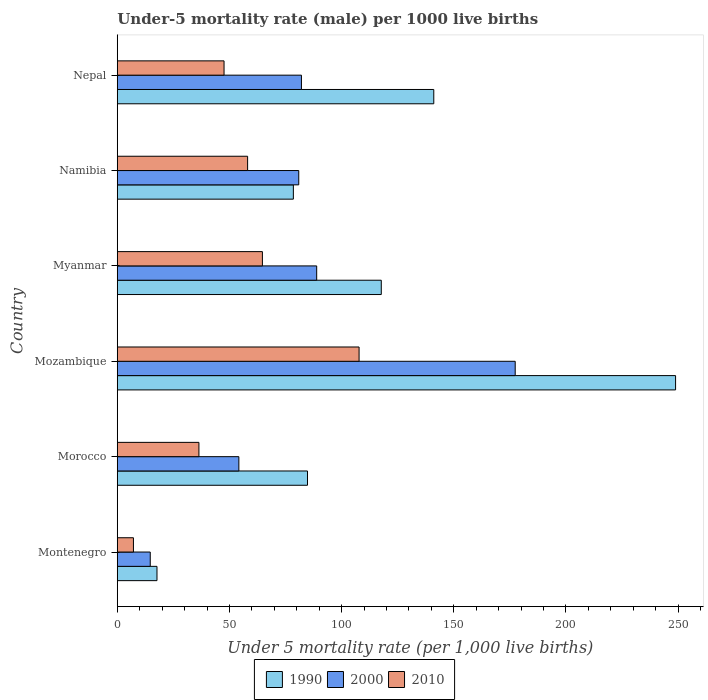How many groups of bars are there?
Ensure brevity in your answer.  6. How many bars are there on the 4th tick from the top?
Your answer should be compact. 3. What is the label of the 5th group of bars from the top?
Keep it short and to the point. Morocco. What is the under-five mortality rate in 1990 in Morocco?
Keep it short and to the point. 84.8. Across all countries, what is the maximum under-five mortality rate in 1990?
Make the answer very short. 248.9. Across all countries, what is the minimum under-five mortality rate in 1990?
Make the answer very short. 17.7. In which country was the under-five mortality rate in 2000 maximum?
Make the answer very short. Mozambique. In which country was the under-five mortality rate in 1990 minimum?
Your answer should be very brief. Montenegro. What is the total under-five mortality rate in 2000 in the graph?
Offer a terse response. 498.2. What is the difference between the under-five mortality rate in 2000 in Namibia and that in Nepal?
Your answer should be compact. -1.2. What is the difference between the under-five mortality rate in 1990 in Namibia and the under-five mortality rate in 2010 in Montenegro?
Offer a terse response. 71.3. What is the average under-five mortality rate in 2000 per country?
Keep it short and to the point. 83.03. In how many countries, is the under-five mortality rate in 2010 greater than 250 ?
Offer a terse response. 0. What is the ratio of the under-five mortality rate in 1990 in Mozambique to that in Myanmar?
Your answer should be very brief. 2.11. Is the difference between the under-five mortality rate in 2010 in Montenegro and Nepal greater than the difference between the under-five mortality rate in 1990 in Montenegro and Nepal?
Your response must be concise. Yes. What is the difference between the highest and the second highest under-five mortality rate in 1990?
Your answer should be compact. 107.8. What is the difference between the highest and the lowest under-five mortality rate in 1990?
Provide a succinct answer. 231.2. What does the 1st bar from the bottom in Morocco represents?
Make the answer very short. 1990. Is it the case that in every country, the sum of the under-five mortality rate in 2000 and under-five mortality rate in 1990 is greater than the under-five mortality rate in 2010?
Keep it short and to the point. Yes. Are all the bars in the graph horizontal?
Your response must be concise. Yes. How many countries are there in the graph?
Provide a succinct answer. 6. How many legend labels are there?
Your response must be concise. 3. What is the title of the graph?
Ensure brevity in your answer.  Under-5 mortality rate (male) per 1000 live births. What is the label or title of the X-axis?
Offer a very short reply. Under 5 mortality rate (per 1,0 live births). What is the Under 5 mortality rate (per 1,000 live births) in 1990 in Montenegro?
Make the answer very short. 17.7. What is the Under 5 mortality rate (per 1,000 live births) of 2000 in Montenegro?
Your answer should be compact. 14.7. What is the Under 5 mortality rate (per 1,000 live births) in 2010 in Montenegro?
Keep it short and to the point. 7.2. What is the Under 5 mortality rate (per 1,000 live births) of 1990 in Morocco?
Keep it short and to the point. 84.8. What is the Under 5 mortality rate (per 1,000 live births) in 2000 in Morocco?
Keep it short and to the point. 54.2. What is the Under 5 mortality rate (per 1,000 live births) of 2010 in Morocco?
Offer a very short reply. 36.4. What is the Under 5 mortality rate (per 1,000 live births) in 1990 in Mozambique?
Offer a terse response. 248.9. What is the Under 5 mortality rate (per 1,000 live births) in 2000 in Mozambique?
Keep it short and to the point. 177.4. What is the Under 5 mortality rate (per 1,000 live births) of 2010 in Mozambique?
Make the answer very short. 107.8. What is the Under 5 mortality rate (per 1,000 live births) of 1990 in Myanmar?
Offer a very short reply. 117.7. What is the Under 5 mortality rate (per 1,000 live births) in 2000 in Myanmar?
Keep it short and to the point. 88.9. What is the Under 5 mortality rate (per 1,000 live births) of 2010 in Myanmar?
Give a very brief answer. 64.7. What is the Under 5 mortality rate (per 1,000 live births) in 1990 in Namibia?
Your response must be concise. 78.5. What is the Under 5 mortality rate (per 1,000 live births) in 2000 in Namibia?
Your response must be concise. 80.9. What is the Under 5 mortality rate (per 1,000 live births) of 2010 in Namibia?
Your answer should be compact. 58.1. What is the Under 5 mortality rate (per 1,000 live births) in 1990 in Nepal?
Ensure brevity in your answer.  141.1. What is the Under 5 mortality rate (per 1,000 live births) of 2000 in Nepal?
Keep it short and to the point. 82.1. What is the Under 5 mortality rate (per 1,000 live births) of 2010 in Nepal?
Offer a very short reply. 47.6. Across all countries, what is the maximum Under 5 mortality rate (per 1,000 live births) in 1990?
Offer a very short reply. 248.9. Across all countries, what is the maximum Under 5 mortality rate (per 1,000 live births) in 2000?
Offer a terse response. 177.4. Across all countries, what is the maximum Under 5 mortality rate (per 1,000 live births) in 2010?
Keep it short and to the point. 107.8. Across all countries, what is the minimum Under 5 mortality rate (per 1,000 live births) of 1990?
Provide a succinct answer. 17.7. Across all countries, what is the minimum Under 5 mortality rate (per 1,000 live births) in 2000?
Offer a terse response. 14.7. What is the total Under 5 mortality rate (per 1,000 live births) in 1990 in the graph?
Provide a succinct answer. 688.7. What is the total Under 5 mortality rate (per 1,000 live births) of 2000 in the graph?
Provide a succinct answer. 498.2. What is the total Under 5 mortality rate (per 1,000 live births) in 2010 in the graph?
Your response must be concise. 321.8. What is the difference between the Under 5 mortality rate (per 1,000 live births) of 1990 in Montenegro and that in Morocco?
Your answer should be compact. -67.1. What is the difference between the Under 5 mortality rate (per 1,000 live births) in 2000 in Montenegro and that in Morocco?
Ensure brevity in your answer.  -39.5. What is the difference between the Under 5 mortality rate (per 1,000 live births) of 2010 in Montenegro and that in Morocco?
Your answer should be compact. -29.2. What is the difference between the Under 5 mortality rate (per 1,000 live births) in 1990 in Montenegro and that in Mozambique?
Give a very brief answer. -231.2. What is the difference between the Under 5 mortality rate (per 1,000 live births) in 2000 in Montenegro and that in Mozambique?
Provide a succinct answer. -162.7. What is the difference between the Under 5 mortality rate (per 1,000 live births) of 2010 in Montenegro and that in Mozambique?
Offer a very short reply. -100.6. What is the difference between the Under 5 mortality rate (per 1,000 live births) in 1990 in Montenegro and that in Myanmar?
Provide a succinct answer. -100. What is the difference between the Under 5 mortality rate (per 1,000 live births) of 2000 in Montenegro and that in Myanmar?
Offer a terse response. -74.2. What is the difference between the Under 5 mortality rate (per 1,000 live births) of 2010 in Montenegro and that in Myanmar?
Your answer should be very brief. -57.5. What is the difference between the Under 5 mortality rate (per 1,000 live births) in 1990 in Montenegro and that in Namibia?
Make the answer very short. -60.8. What is the difference between the Under 5 mortality rate (per 1,000 live births) in 2000 in Montenegro and that in Namibia?
Provide a short and direct response. -66.2. What is the difference between the Under 5 mortality rate (per 1,000 live births) of 2010 in Montenegro and that in Namibia?
Your answer should be compact. -50.9. What is the difference between the Under 5 mortality rate (per 1,000 live births) in 1990 in Montenegro and that in Nepal?
Your answer should be compact. -123.4. What is the difference between the Under 5 mortality rate (per 1,000 live births) of 2000 in Montenegro and that in Nepal?
Give a very brief answer. -67.4. What is the difference between the Under 5 mortality rate (per 1,000 live births) in 2010 in Montenegro and that in Nepal?
Your answer should be very brief. -40.4. What is the difference between the Under 5 mortality rate (per 1,000 live births) of 1990 in Morocco and that in Mozambique?
Make the answer very short. -164.1. What is the difference between the Under 5 mortality rate (per 1,000 live births) in 2000 in Morocco and that in Mozambique?
Offer a very short reply. -123.2. What is the difference between the Under 5 mortality rate (per 1,000 live births) of 2010 in Morocco and that in Mozambique?
Offer a very short reply. -71.4. What is the difference between the Under 5 mortality rate (per 1,000 live births) of 1990 in Morocco and that in Myanmar?
Provide a succinct answer. -32.9. What is the difference between the Under 5 mortality rate (per 1,000 live births) in 2000 in Morocco and that in Myanmar?
Keep it short and to the point. -34.7. What is the difference between the Under 5 mortality rate (per 1,000 live births) of 2010 in Morocco and that in Myanmar?
Ensure brevity in your answer.  -28.3. What is the difference between the Under 5 mortality rate (per 1,000 live births) of 1990 in Morocco and that in Namibia?
Offer a terse response. 6.3. What is the difference between the Under 5 mortality rate (per 1,000 live births) in 2000 in Morocco and that in Namibia?
Your answer should be compact. -26.7. What is the difference between the Under 5 mortality rate (per 1,000 live births) in 2010 in Morocco and that in Namibia?
Ensure brevity in your answer.  -21.7. What is the difference between the Under 5 mortality rate (per 1,000 live births) in 1990 in Morocco and that in Nepal?
Keep it short and to the point. -56.3. What is the difference between the Under 5 mortality rate (per 1,000 live births) of 2000 in Morocco and that in Nepal?
Ensure brevity in your answer.  -27.9. What is the difference between the Under 5 mortality rate (per 1,000 live births) of 2010 in Morocco and that in Nepal?
Ensure brevity in your answer.  -11.2. What is the difference between the Under 5 mortality rate (per 1,000 live births) of 1990 in Mozambique and that in Myanmar?
Provide a succinct answer. 131.2. What is the difference between the Under 5 mortality rate (per 1,000 live births) in 2000 in Mozambique and that in Myanmar?
Offer a very short reply. 88.5. What is the difference between the Under 5 mortality rate (per 1,000 live births) of 2010 in Mozambique and that in Myanmar?
Give a very brief answer. 43.1. What is the difference between the Under 5 mortality rate (per 1,000 live births) in 1990 in Mozambique and that in Namibia?
Provide a short and direct response. 170.4. What is the difference between the Under 5 mortality rate (per 1,000 live births) in 2000 in Mozambique and that in Namibia?
Your response must be concise. 96.5. What is the difference between the Under 5 mortality rate (per 1,000 live births) in 2010 in Mozambique and that in Namibia?
Offer a very short reply. 49.7. What is the difference between the Under 5 mortality rate (per 1,000 live births) of 1990 in Mozambique and that in Nepal?
Make the answer very short. 107.8. What is the difference between the Under 5 mortality rate (per 1,000 live births) in 2000 in Mozambique and that in Nepal?
Your answer should be compact. 95.3. What is the difference between the Under 5 mortality rate (per 1,000 live births) in 2010 in Mozambique and that in Nepal?
Your answer should be compact. 60.2. What is the difference between the Under 5 mortality rate (per 1,000 live births) of 1990 in Myanmar and that in Namibia?
Provide a short and direct response. 39.2. What is the difference between the Under 5 mortality rate (per 1,000 live births) of 2000 in Myanmar and that in Namibia?
Your response must be concise. 8. What is the difference between the Under 5 mortality rate (per 1,000 live births) of 1990 in Myanmar and that in Nepal?
Make the answer very short. -23.4. What is the difference between the Under 5 mortality rate (per 1,000 live births) of 2010 in Myanmar and that in Nepal?
Give a very brief answer. 17.1. What is the difference between the Under 5 mortality rate (per 1,000 live births) in 1990 in Namibia and that in Nepal?
Offer a very short reply. -62.6. What is the difference between the Under 5 mortality rate (per 1,000 live births) of 2000 in Namibia and that in Nepal?
Your answer should be compact. -1.2. What is the difference between the Under 5 mortality rate (per 1,000 live births) of 1990 in Montenegro and the Under 5 mortality rate (per 1,000 live births) of 2000 in Morocco?
Give a very brief answer. -36.5. What is the difference between the Under 5 mortality rate (per 1,000 live births) in 1990 in Montenegro and the Under 5 mortality rate (per 1,000 live births) in 2010 in Morocco?
Offer a terse response. -18.7. What is the difference between the Under 5 mortality rate (per 1,000 live births) in 2000 in Montenegro and the Under 5 mortality rate (per 1,000 live births) in 2010 in Morocco?
Provide a short and direct response. -21.7. What is the difference between the Under 5 mortality rate (per 1,000 live births) of 1990 in Montenegro and the Under 5 mortality rate (per 1,000 live births) of 2000 in Mozambique?
Your answer should be compact. -159.7. What is the difference between the Under 5 mortality rate (per 1,000 live births) in 1990 in Montenegro and the Under 5 mortality rate (per 1,000 live births) in 2010 in Mozambique?
Your answer should be very brief. -90.1. What is the difference between the Under 5 mortality rate (per 1,000 live births) in 2000 in Montenegro and the Under 5 mortality rate (per 1,000 live births) in 2010 in Mozambique?
Offer a terse response. -93.1. What is the difference between the Under 5 mortality rate (per 1,000 live births) of 1990 in Montenegro and the Under 5 mortality rate (per 1,000 live births) of 2000 in Myanmar?
Provide a succinct answer. -71.2. What is the difference between the Under 5 mortality rate (per 1,000 live births) in 1990 in Montenegro and the Under 5 mortality rate (per 1,000 live births) in 2010 in Myanmar?
Keep it short and to the point. -47. What is the difference between the Under 5 mortality rate (per 1,000 live births) of 1990 in Montenegro and the Under 5 mortality rate (per 1,000 live births) of 2000 in Namibia?
Provide a succinct answer. -63.2. What is the difference between the Under 5 mortality rate (per 1,000 live births) in 1990 in Montenegro and the Under 5 mortality rate (per 1,000 live births) in 2010 in Namibia?
Your response must be concise. -40.4. What is the difference between the Under 5 mortality rate (per 1,000 live births) of 2000 in Montenegro and the Under 5 mortality rate (per 1,000 live births) of 2010 in Namibia?
Keep it short and to the point. -43.4. What is the difference between the Under 5 mortality rate (per 1,000 live births) of 1990 in Montenegro and the Under 5 mortality rate (per 1,000 live births) of 2000 in Nepal?
Your answer should be very brief. -64.4. What is the difference between the Under 5 mortality rate (per 1,000 live births) of 1990 in Montenegro and the Under 5 mortality rate (per 1,000 live births) of 2010 in Nepal?
Provide a succinct answer. -29.9. What is the difference between the Under 5 mortality rate (per 1,000 live births) in 2000 in Montenegro and the Under 5 mortality rate (per 1,000 live births) in 2010 in Nepal?
Ensure brevity in your answer.  -32.9. What is the difference between the Under 5 mortality rate (per 1,000 live births) of 1990 in Morocco and the Under 5 mortality rate (per 1,000 live births) of 2000 in Mozambique?
Offer a very short reply. -92.6. What is the difference between the Under 5 mortality rate (per 1,000 live births) of 2000 in Morocco and the Under 5 mortality rate (per 1,000 live births) of 2010 in Mozambique?
Provide a short and direct response. -53.6. What is the difference between the Under 5 mortality rate (per 1,000 live births) in 1990 in Morocco and the Under 5 mortality rate (per 1,000 live births) in 2000 in Myanmar?
Your answer should be very brief. -4.1. What is the difference between the Under 5 mortality rate (per 1,000 live births) in 1990 in Morocco and the Under 5 mortality rate (per 1,000 live births) in 2010 in Myanmar?
Your answer should be compact. 20.1. What is the difference between the Under 5 mortality rate (per 1,000 live births) in 2000 in Morocco and the Under 5 mortality rate (per 1,000 live births) in 2010 in Myanmar?
Provide a short and direct response. -10.5. What is the difference between the Under 5 mortality rate (per 1,000 live births) in 1990 in Morocco and the Under 5 mortality rate (per 1,000 live births) in 2000 in Namibia?
Provide a short and direct response. 3.9. What is the difference between the Under 5 mortality rate (per 1,000 live births) in 1990 in Morocco and the Under 5 mortality rate (per 1,000 live births) in 2010 in Namibia?
Ensure brevity in your answer.  26.7. What is the difference between the Under 5 mortality rate (per 1,000 live births) in 1990 in Morocco and the Under 5 mortality rate (per 1,000 live births) in 2010 in Nepal?
Ensure brevity in your answer.  37.2. What is the difference between the Under 5 mortality rate (per 1,000 live births) in 2000 in Morocco and the Under 5 mortality rate (per 1,000 live births) in 2010 in Nepal?
Give a very brief answer. 6.6. What is the difference between the Under 5 mortality rate (per 1,000 live births) of 1990 in Mozambique and the Under 5 mortality rate (per 1,000 live births) of 2000 in Myanmar?
Offer a terse response. 160. What is the difference between the Under 5 mortality rate (per 1,000 live births) of 1990 in Mozambique and the Under 5 mortality rate (per 1,000 live births) of 2010 in Myanmar?
Give a very brief answer. 184.2. What is the difference between the Under 5 mortality rate (per 1,000 live births) in 2000 in Mozambique and the Under 5 mortality rate (per 1,000 live births) in 2010 in Myanmar?
Your answer should be compact. 112.7. What is the difference between the Under 5 mortality rate (per 1,000 live births) of 1990 in Mozambique and the Under 5 mortality rate (per 1,000 live births) of 2000 in Namibia?
Provide a short and direct response. 168. What is the difference between the Under 5 mortality rate (per 1,000 live births) in 1990 in Mozambique and the Under 5 mortality rate (per 1,000 live births) in 2010 in Namibia?
Your response must be concise. 190.8. What is the difference between the Under 5 mortality rate (per 1,000 live births) of 2000 in Mozambique and the Under 5 mortality rate (per 1,000 live births) of 2010 in Namibia?
Keep it short and to the point. 119.3. What is the difference between the Under 5 mortality rate (per 1,000 live births) in 1990 in Mozambique and the Under 5 mortality rate (per 1,000 live births) in 2000 in Nepal?
Give a very brief answer. 166.8. What is the difference between the Under 5 mortality rate (per 1,000 live births) of 1990 in Mozambique and the Under 5 mortality rate (per 1,000 live births) of 2010 in Nepal?
Keep it short and to the point. 201.3. What is the difference between the Under 5 mortality rate (per 1,000 live births) of 2000 in Mozambique and the Under 5 mortality rate (per 1,000 live births) of 2010 in Nepal?
Give a very brief answer. 129.8. What is the difference between the Under 5 mortality rate (per 1,000 live births) in 1990 in Myanmar and the Under 5 mortality rate (per 1,000 live births) in 2000 in Namibia?
Keep it short and to the point. 36.8. What is the difference between the Under 5 mortality rate (per 1,000 live births) in 1990 in Myanmar and the Under 5 mortality rate (per 1,000 live births) in 2010 in Namibia?
Give a very brief answer. 59.6. What is the difference between the Under 5 mortality rate (per 1,000 live births) of 2000 in Myanmar and the Under 5 mortality rate (per 1,000 live births) of 2010 in Namibia?
Ensure brevity in your answer.  30.8. What is the difference between the Under 5 mortality rate (per 1,000 live births) in 1990 in Myanmar and the Under 5 mortality rate (per 1,000 live births) in 2000 in Nepal?
Give a very brief answer. 35.6. What is the difference between the Under 5 mortality rate (per 1,000 live births) in 1990 in Myanmar and the Under 5 mortality rate (per 1,000 live births) in 2010 in Nepal?
Provide a short and direct response. 70.1. What is the difference between the Under 5 mortality rate (per 1,000 live births) of 2000 in Myanmar and the Under 5 mortality rate (per 1,000 live births) of 2010 in Nepal?
Offer a very short reply. 41.3. What is the difference between the Under 5 mortality rate (per 1,000 live births) in 1990 in Namibia and the Under 5 mortality rate (per 1,000 live births) in 2000 in Nepal?
Your answer should be very brief. -3.6. What is the difference between the Under 5 mortality rate (per 1,000 live births) of 1990 in Namibia and the Under 5 mortality rate (per 1,000 live births) of 2010 in Nepal?
Your answer should be compact. 30.9. What is the difference between the Under 5 mortality rate (per 1,000 live births) in 2000 in Namibia and the Under 5 mortality rate (per 1,000 live births) in 2010 in Nepal?
Offer a terse response. 33.3. What is the average Under 5 mortality rate (per 1,000 live births) of 1990 per country?
Your response must be concise. 114.78. What is the average Under 5 mortality rate (per 1,000 live births) of 2000 per country?
Give a very brief answer. 83.03. What is the average Under 5 mortality rate (per 1,000 live births) in 2010 per country?
Make the answer very short. 53.63. What is the difference between the Under 5 mortality rate (per 1,000 live births) in 1990 and Under 5 mortality rate (per 1,000 live births) in 2010 in Montenegro?
Provide a short and direct response. 10.5. What is the difference between the Under 5 mortality rate (per 1,000 live births) of 1990 and Under 5 mortality rate (per 1,000 live births) of 2000 in Morocco?
Keep it short and to the point. 30.6. What is the difference between the Under 5 mortality rate (per 1,000 live births) of 1990 and Under 5 mortality rate (per 1,000 live births) of 2010 in Morocco?
Give a very brief answer. 48.4. What is the difference between the Under 5 mortality rate (per 1,000 live births) in 2000 and Under 5 mortality rate (per 1,000 live births) in 2010 in Morocco?
Offer a terse response. 17.8. What is the difference between the Under 5 mortality rate (per 1,000 live births) of 1990 and Under 5 mortality rate (per 1,000 live births) of 2000 in Mozambique?
Your answer should be compact. 71.5. What is the difference between the Under 5 mortality rate (per 1,000 live births) of 1990 and Under 5 mortality rate (per 1,000 live births) of 2010 in Mozambique?
Keep it short and to the point. 141.1. What is the difference between the Under 5 mortality rate (per 1,000 live births) in 2000 and Under 5 mortality rate (per 1,000 live births) in 2010 in Mozambique?
Give a very brief answer. 69.6. What is the difference between the Under 5 mortality rate (per 1,000 live births) in 1990 and Under 5 mortality rate (per 1,000 live births) in 2000 in Myanmar?
Offer a very short reply. 28.8. What is the difference between the Under 5 mortality rate (per 1,000 live births) of 1990 and Under 5 mortality rate (per 1,000 live births) of 2010 in Myanmar?
Ensure brevity in your answer.  53. What is the difference between the Under 5 mortality rate (per 1,000 live births) of 2000 and Under 5 mortality rate (per 1,000 live births) of 2010 in Myanmar?
Ensure brevity in your answer.  24.2. What is the difference between the Under 5 mortality rate (per 1,000 live births) of 1990 and Under 5 mortality rate (per 1,000 live births) of 2010 in Namibia?
Ensure brevity in your answer.  20.4. What is the difference between the Under 5 mortality rate (per 1,000 live births) of 2000 and Under 5 mortality rate (per 1,000 live births) of 2010 in Namibia?
Your response must be concise. 22.8. What is the difference between the Under 5 mortality rate (per 1,000 live births) of 1990 and Under 5 mortality rate (per 1,000 live births) of 2000 in Nepal?
Offer a terse response. 59. What is the difference between the Under 5 mortality rate (per 1,000 live births) in 1990 and Under 5 mortality rate (per 1,000 live births) in 2010 in Nepal?
Give a very brief answer. 93.5. What is the difference between the Under 5 mortality rate (per 1,000 live births) in 2000 and Under 5 mortality rate (per 1,000 live births) in 2010 in Nepal?
Provide a succinct answer. 34.5. What is the ratio of the Under 5 mortality rate (per 1,000 live births) of 1990 in Montenegro to that in Morocco?
Offer a very short reply. 0.21. What is the ratio of the Under 5 mortality rate (per 1,000 live births) in 2000 in Montenegro to that in Morocco?
Provide a short and direct response. 0.27. What is the ratio of the Under 5 mortality rate (per 1,000 live births) in 2010 in Montenegro to that in Morocco?
Provide a succinct answer. 0.2. What is the ratio of the Under 5 mortality rate (per 1,000 live births) in 1990 in Montenegro to that in Mozambique?
Ensure brevity in your answer.  0.07. What is the ratio of the Under 5 mortality rate (per 1,000 live births) of 2000 in Montenegro to that in Mozambique?
Ensure brevity in your answer.  0.08. What is the ratio of the Under 5 mortality rate (per 1,000 live births) of 2010 in Montenegro to that in Mozambique?
Your answer should be very brief. 0.07. What is the ratio of the Under 5 mortality rate (per 1,000 live births) in 1990 in Montenegro to that in Myanmar?
Provide a succinct answer. 0.15. What is the ratio of the Under 5 mortality rate (per 1,000 live births) of 2000 in Montenegro to that in Myanmar?
Provide a short and direct response. 0.17. What is the ratio of the Under 5 mortality rate (per 1,000 live births) of 2010 in Montenegro to that in Myanmar?
Give a very brief answer. 0.11. What is the ratio of the Under 5 mortality rate (per 1,000 live births) in 1990 in Montenegro to that in Namibia?
Provide a short and direct response. 0.23. What is the ratio of the Under 5 mortality rate (per 1,000 live births) in 2000 in Montenegro to that in Namibia?
Provide a short and direct response. 0.18. What is the ratio of the Under 5 mortality rate (per 1,000 live births) of 2010 in Montenegro to that in Namibia?
Give a very brief answer. 0.12. What is the ratio of the Under 5 mortality rate (per 1,000 live births) in 1990 in Montenegro to that in Nepal?
Give a very brief answer. 0.13. What is the ratio of the Under 5 mortality rate (per 1,000 live births) of 2000 in Montenegro to that in Nepal?
Offer a terse response. 0.18. What is the ratio of the Under 5 mortality rate (per 1,000 live births) in 2010 in Montenegro to that in Nepal?
Keep it short and to the point. 0.15. What is the ratio of the Under 5 mortality rate (per 1,000 live births) in 1990 in Morocco to that in Mozambique?
Your answer should be very brief. 0.34. What is the ratio of the Under 5 mortality rate (per 1,000 live births) in 2000 in Morocco to that in Mozambique?
Your response must be concise. 0.31. What is the ratio of the Under 5 mortality rate (per 1,000 live births) of 2010 in Morocco to that in Mozambique?
Your response must be concise. 0.34. What is the ratio of the Under 5 mortality rate (per 1,000 live births) in 1990 in Morocco to that in Myanmar?
Make the answer very short. 0.72. What is the ratio of the Under 5 mortality rate (per 1,000 live births) of 2000 in Morocco to that in Myanmar?
Ensure brevity in your answer.  0.61. What is the ratio of the Under 5 mortality rate (per 1,000 live births) of 2010 in Morocco to that in Myanmar?
Provide a short and direct response. 0.56. What is the ratio of the Under 5 mortality rate (per 1,000 live births) of 1990 in Morocco to that in Namibia?
Make the answer very short. 1.08. What is the ratio of the Under 5 mortality rate (per 1,000 live births) of 2000 in Morocco to that in Namibia?
Keep it short and to the point. 0.67. What is the ratio of the Under 5 mortality rate (per 1,000 live births) of 2010 in Morocco to that in Namibia?
Make the answer very short. 0.63. What is the ratio of the Under 5 mortality rate (per 1,000 live births) of 1990 in Morocco to that in Nepal?
Your answer should be compact. 0.6. What is the ratio of the Under 5 mortality rate (per 1,000 live births) in 2000 in Morocco to that in Nepal?
Your answer should be very brief. 0.66. What is the ratio of the Under 5 mortality rate (per 1,000 live births) of 2010 in Morocco to that in Nepal?
Make the answer very short. 0.76. What is the ratio of the Under 5 mortality rate (per 1,000 live births) in 1990 in Mozambique to that in Myanmar?
Make the answer very short. 2.11. What is the ratio of the Under 5 mortality rate (per 1,000 live births) in 2000 in Mozambique to that in Myanmar?
Offer a terse response. 2. What is the ratio of the Under 5 mortality rate (per 1,000 live births) of 2010 in Mozambique to that in Myanmar?
Offer a very short reply. 1.67. What is the ratio of the Under 5 mortality rate (per 1,000 live births) in 1990 in Mozambique to that in Namibia?
Make the answer very short. 3.17. What is the ratio of the Under 5 mortality rate (per 1,000 live births) in 2000 in Mozambique to that in Namibia?
Your response must be concise. 2.19. What is the ratio of the Under 5 mortality rate (per 1,000 live births) of 2010 in Mozambique to that in Namibia?
Provide a succinct answer. 1.86. What is the ratio of the Under 5 mortality rate (per 1,000 live births) in 1990 in Mozambique to that in Nepal?
Your answer should be compact. 1.76. What is the ratio of the Under 5 mortality rate (per 1,000 live births) in 2000 in Mozambique to that in Nepal?
Keep it short and to the point. 2.16. What is the ratio of the Under 5 mortality rate (per 1,000 live births) in 2010 in Mozambique to that in Nepal?
Provide a short and direct response. 2.26. What is the ratio of the Under 5 mortality rate (per 1,000 live births) of 1990 in Myanmar to that in Namibia?
Offer a terse response. 1.5. What is the ratio of the Under 5 mortality rate (per 1,000 live births) of 2000 in Myanmar to that in Namibia?
Keep it short and to the point. 1.1. What is the ratio of the Under 5 mortality rate (per 1,000 live births) in 2010 in Myanmar to that in Namibia?
Provide a short and direct response. 1.11. What is the ratio of the Under 5 mortality rate (per 1,000 live births) of 1990 in Myanmar to that in Nepal?
Your answer should be compact. 0.83. What is the ratio of the Under 5 mortality rate (per 1,000 live births) of 2000 in Myanmar to that in Nepal?
Give a very brief answer. 1.08. What is the ratio of the Under 5 mortality rate (per 1,000 live births) in 2010 in Myanmar to that in Nepal?
Your answer should be very brief. 1.36. What is the ratio of the Under 5 mortality rate (per 1,000 live births) of 1990 in Namibia to that in Nepal?
Your answer should be compact. 0.56. What is the ratio of the Under 5 mortality rate (per 1,000 live births) in 2000 in Namibia to that in Nepal?
Your response must be concise. 0.99. What is the ratio of the Under 5 mortality rate (per 1,000 live births) in 2010 in Namibia to that in Nepal?
Keep it short and to the point. 1.22. What is the difference between the highest and the second highest Under 5 mortality rate (per 1,000 live births) of 1990?
Offer a terse response. 107.8. What is the difference between the highest and the second highest Under 5 mortality rate (per 1,000 live births) of 2000?
Offer a very short reply. 88.5. What is the difference between the highest and the second highest Under 5 mortality rate (per 1,000 live births) of 2010?
Make the answer very short. 43.1. What is the difference between the highest and the lowest Under 5 mortality rate (per 1,000 live births) in 1990?
Offer a very short reply. 231.2. What is the difference between the highest and the lowest Under 5 mortality rate (per 1,000 live births) in 2000?
Ensure brevity in your answer.  162.7. What is the difference between the highest and the lowest Under 5 mortality rate (per 1,000 live births) in 2010?
Your answer should be compact. 100.6. 